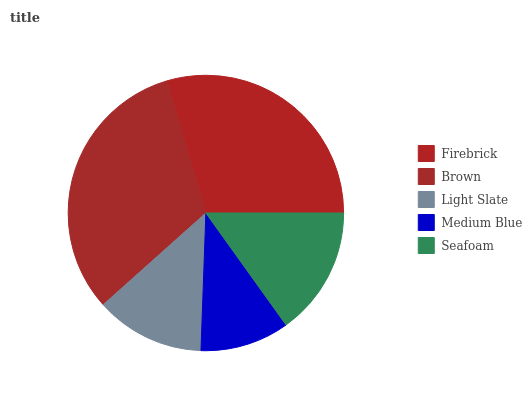Is Medium Blue the minimum?
Answer yes or no. Yes. Is Brown the maximum?
Answer yes or no. Yes. Is Light Slate the minimum?
Answer yes or no. No. Is Light Slate the maximum?
Answer yes or no. No. Is Brown greater than Light Slate?
Answer yes or no. Yes. Is Light Slate less than Brown?
Answer yes or no. Yes. Is Light Slate greater than Brown?
Answer yes or no. No. Is Brown less than Light Slate?
Answer yes or no. No. Is Seafoam the high median?
Answer yes or no. Yes. Is Seafoam the low median?
Answer yes or no. Yes. Is Firebrick the high median?
Answer yes or no. No. Is Medium Blue the low median?
Answer yes or no. No. 